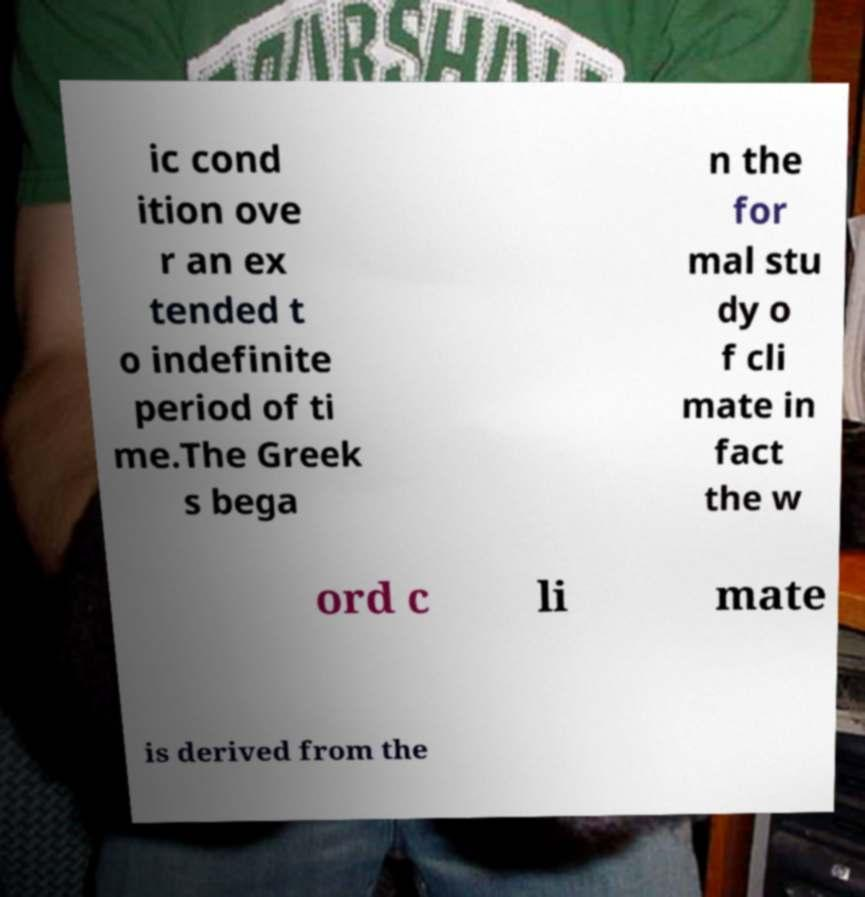Could you assist in decoding the text presented in this image and type it out clearly? ic cond ition ove r an ex tended t o indefinite period of ti me.The Greek s bega n the for mal stu dy o f cli mate in fact the w ord c li mate is derived from the 